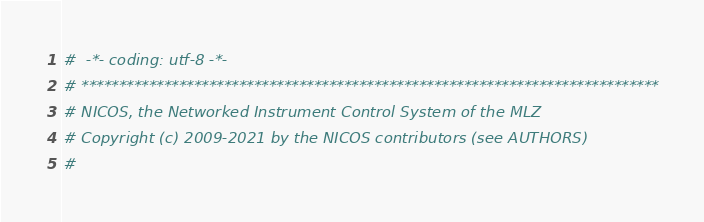Convert code to text. <code><loc_0><loc_0><loc_500><loc_500><_Python_>#  -*- coding: utf-8 -*-
# *****************************************************************************
# NICOS, the Networked Instrument Control System of the MLZ
# Copyright (c) 2009-2021 by the NICOS contributors (see AUTHORS)
#</code> 